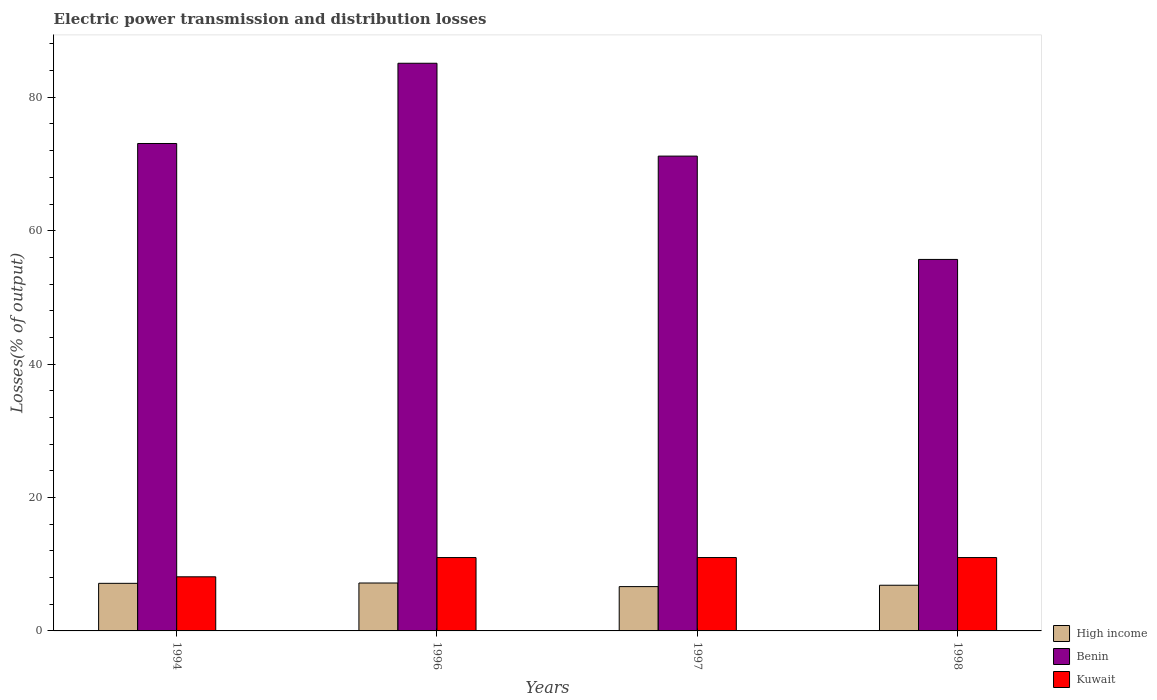How many different coloured bars are there?
Keep it short and to the point. 3. How many groups of bars are there?
Keep it short and to the point. 4. Are the number of bars per tick equal to the number of legend labels?
Keep it short and to the point. Yes. Are the number of bars on each tick of the X-axis equal?
Your answer should be compact. Yes. What is the electric power transmission and distribution losses in High income in 1994?
Provide a succinct answer. 7.14. Across all years, what is the maximum electric power transmission and distribution losses in Benin?
Provide a succinct answer. 85.11. Across all years, what is the minimum electric power transmission and distribution losses in Benin?
Keep it short and to the point. 55.7. In which year was the electric power transmission and distribution losses in High income maximum?
Your answer should be compact. 1996. In which year was the electric power transmission and distribution losses in Kuwait minimum?
Provide a short and direct response. 1994. What is the total electric power transmission and distribution losses in High income in the graph?
Make the answer very short. 27.81. What is the difference between the electric power transmission and distribution losses in Benin in 1997 and that in 1998?
Keep it short and to the point. 15.49. What is the difference between the electric power transmission and distribution losses in Benin in 1997 and the electric power transmission and distribution losses in High income in 1994?
Provide a succinct answer. 64.05. What is the average electric power transmission and distribution losses in Kuwait per year?
Your answer should be very brief. 10.28. In the year 1996, what is the difference between the electric power transmission and distribution losses in High income and electric power transmission and distribution losses in Kuwait?
Ensure brevity in your answer.  -3.82. What is the ratio of the electric power transmission and distribution losses in Kuwait in 1994 to that in 1997?
Provide a short and direct response. 0.74. Is the electric power transmission and distribution losses in High income in 1994 less than that in 1997?
Provide a short and direct response. No. Is the difference between the electric power transmission and distribution losses in High income in 1997 and 1998 greater than the difference between the electric power transmission and distribution losses in Kuwait in 1997 and 1998?
Provide a succinct answer. No. What is the difference between the highest and the second highest electric power transmission and distribution losses in Benin?
Make the answer very short. 12.03. What is the difference between the highest and the lowest electric power transmission and distribution losses in High income?
Give a very brief answer. 0.54. Is the sum of the electric power transmission and distribution losses in High income in 1994 and 1996 greater than the maximum electric power transmission and distribution losses in Benin across all years?
Give a very brief answer. No. What does the 3rd bar from the left in 1998 represents?
Provide a short and direct response. Kuwait. What does the 2nd bar from the right in 1998 represents?
Offer a terse response. Benin. How many years are there in the graph?
Offer a terse response. 4. What is the difference between two consecutive major ticks on the Y-axis?
Your response must be concise. 20. Are the values on the major ticks of Y-axis written in scientific E-notation?
Make the answer very short. No. Does the graph contain any zero values?
Provide a succinct answer. No. Does the graph contain grids?
Your answer should be very brief. No. Where does the legend appear in the graph?
Your response must be concise. Bottom right. How many legend labels are there?
Ensure brevity in your answer.  3. What is the title of the graph?
Your answer should be compact. Electric power transmission and distribution losses. Does "Australia" appear as one of the legend labels in the graph?
Your response must be concise. No. What is the label or title of the X-axis?
Your answer should be compact. Years. What is the label or title of the Y-axis?
Your response must be concise. Losses(% of output). What is the Losses(% of output) of High income in 1994?
Your response must be concise. 7.14. What is the Losses(% of output) of Benin in 1994?
Keep it short and to the point. 73.08. What is the Losses(% of output) in Kuwait in 1994?
Your answer should be very brief. 8.11. What is the Losses(% of output) in High income in 1996?
Make the answer very short. 7.18. What is the Losses(% of output) in Benin in 1996?
Offer a very short reply. 85.11. What is the Losses(% of output) of Kuwait in 1996?
Offer a very short reply. 11. What is the Losses(% of output) in High income in 1997?
Your answer should be very brief. 6.64. What is the Losses(% of output) in Benin in 1997?
Make the answer very short. 71.19. What is the Losses(% of output) in Kuwait in 1997?
Your answer should be compact. 11. What is the Losses(% of output) of High income in 1998?
Your answer should be very brief. 6.85. What is the Losses(% of output) of Benin in 1998?
Your answer should be compact. 55.7. What is the Losses(% of output) of Kuwait in 1998?
Your answer should be very brief. 11. Across all years, what is the maximum Losses(% of output) in High income?
Offer a terse response. 7.18. Across all years, what is the maximum Losses(% of output) of Benin?
Give a very brief answer. 85.11. Across all years, what is the maximum Losses(% of output) in Kuwait?
Provide a succinct answer. 11. Across all years, what is the minimum Losses(% of output) of High income?
Your answer should be compact. 6.64. Across all years, what is the minimum Losses(% of output) of Benin?
Provide a succinct answer. 55.7. Across all years, what is the minimum Losses(% of output) in Kuwait?
Your answer should be compact. 8.11. What is the total Losses(% of output) in High income in the graph?
Provide a succinct answer. 27.81. What is the total Losses(% of output) in Benin in the graph?
Your response must be concise. 285.07. What is the total Losses(% of output) of Kuwait in the graph?
Make the answer very short. 41.11. What is the difference between the Losses(% of output) in High income in 1994 and that in 1996?
Provide a short and direct response. -0.05. What is the difference between the Losses(% of output) of Benin in 1994 and that in 1996?
Ensure brevity in your answer.  -12.03. What is the difference between the Losses(% of output) in Kuwait in 1994 and that in 1996?
Offer a terse response. -2.89. What is the difference between the Losses(% of output) in High income in 1994 and that in 1997?
Offer a terse response. 0.49. What is the difference between the Losses(% of output) in Benin in 1994 and that in 1997?
Offer a terse response. 1.89. What is the difference between the Losses(% of output) of Kuwait in 1994 and that in 1997?
Ensure brevity in your answer.  -2.89. What is the difference between the Losses(% of output) of High income in 1994 and that in 1998?
Make the answer very short. 0.29. What is the difference between the Losses(% of output) in Benin in 1994 and that in 1998?
Your answer should be compact. 17.38. What is the difference between the Losses(% of output) in Kuwait in 1994 and that in 1998?
Offer a very short reply. -2.89. What is the difference between the Losses(% of output) of High income in 1996 and that in 1997?
Keep it short and to the point. 0.54. What is the difference between the Losses(% of output) in Benin in 1996 and that in 1997?
Offer a very short reply. 13.92. What is the difference between the Losses(% of output) in Kuwait in 1996 and that in 1997?
Make the answer very short. -0. What is the difference between the Losses(% of output) in High income in 1996 and that in 1998?
Keep it short and to the point. 0.34. What is the difference between the Losses(% of output) in Benin in 1996 and that in 1998?
Ensure brevity in your answer.  29.41. What is the difference between the Losses(% of output) of Kuwait in 1996 and that in 1998?
Your response must be concise. -0. What is the difference between the Losses(% of output) in High income in 1997 and that in 1998?
Offer a terse response. -0.2. What is the difference between the Losses(% of output) of Benin in 1997 and that in 1998?
Your response must be concise. 15.49. What is the difference between the Losses(% of output) in Kuwait in 1997 and that in 1998?
Your response must be concise. 0. What is the difference between the Losses(% of output) of High income in 1994 and the Losses(% of output) of Benin in 1996?
Make the answer very short. -77.97. What is the difference between the Losses(% of output) in High income in 1994 and the Losses(% of output) in Kuwait in 1996?
Your response must be concise. -3.86. What is the difference between the Losses(% of output) of Benin in 1994 and the Losses(% of output) of Kuwait in 1996?
Your response must be concise. 62.08. What is the difference between the Losses(% of output) of High income in 1994 and the Losses(% of output) of Benin in 1997?
Offer a terse response. -64.05. What is the difference between the Losses(% of output) of High income in 1994 and the Losses(% of output) of Kuwait in 1997?
Offer a very short reply. -3.87. What is the difference between the Losses(% of output) in Benin in 1994 and the Losses(% of output) in Kuwait in 1997?
Your answer should be very brief. 62.08. What is the difference between the Losses(% of output) of High income in 1994 and the Losses(% of output) of Benin in 1998?
Your answer should be compact. -48.56. What is the difference between the Losses(% of output) in High income in 1994 and the Losses(% of output) in Kuwait in 1998?
Your answer should be compact. -3.86. What is the difference between the Losses(% of output) in Benin in 1994 and the Losses(% of output) in Kuwait in 1998?
Your response must be concise. 62.08. What is the difference between the Losses(% of output) of High income in 1996 and the Losses(% of output) of Benin in 1997?
Offer a very short reply. -64. What is the difference between the Losses(% of output) in High income in 1996 and the Losses(% of output) in Kuwait in 1997?
Your answer should be very brief. -3.82. What is the difference between the Losses(% of output) in Benin in 1996 and the Losses(% of output) in Kuwait in 1997?
Give a very brief answer. 74.11. What is the difference between the Losses(% of output) in High income in 1996 and the Losses(% of output) in Benin in 1998?
Offer a very short reply. -48.51. What is the difference between the Losses(% of output) of High income in 1996 and the Losses(% of output) of Kuwait in 1998?
Provide a succinct answer. -3.82. What is the difference between the Losses(% of output) of Benin in 1996 and the Losses(% of output) of Kuwait in 1998?
Provide a succinct answer. 74.11. What is the difference between the Losses(% of output) in High income in 1997 and the Losses(% of output) in Benin in 1998?
Make the answer very short. -49.05. What is the difference between the Losses(% of output) of High income in 1997 and the Losses(% of output) of Kuwait in 1998?
Offer a terse response. -4.35. What is the difference between the Losses(% of output) of Benin in 1997 and the Losses(% of output) of Kuwait in 1998?
Give a very brief answer. 60.19. What is the average Losses(% of output) of High income per year?
Ensure brevity in your answer.  6.95. What is the average Losses(% of output) in Benin per year?
Keep it short and to the point. 71.27. What is the average Losses(% of output) in Kuwait per year?
Keep it short and to the point. 10.28. In the year 1994, what is the difference between the Losses(% of output) in High income and Losses(% of output) in Benin?
Give a very brief answer. -65.94. In the year 1994, what is the difference between the Losses(% of output) in High income and Losses(% of output) in Kuwait?
Your response must be concise. -0.98. In the year 1994, what is the difference between the Losses(% of output) of Benin and Losses(% of output) of Kuwait?
Offer a terse response. 64.96. In the year 1996, what is the difference between the Losses(% of output) in High income and Losses(% of output) in Benin?
Keep it short and to the point. -77.92. In the year 1996, what is the difference between the Losses(% of output) of High income and Losses(% of output) of Kuwait?
Your response must be concise. -3.82. In the year 1996, what is the difference between the Losses(% of output) of Benin and Losses(% of output) of Kuwait?
Offer a terse response. 74.11. In the year 1997, what is the difference between the Losses(% of output) in High income and Losses(% of output) in Benin?
Provide a short and direct response. -64.54. In the year 1997, what is the difference between the Losses(% of output) in High income and Losses(% of output) in Kuwait?
Make the answer very short. -4.36. In the year 1997, what is the difference between the Losses(% of output) of Benin and Losses(% of output) of Kuwait?
Keep it short and to the point. 60.19. In the year 1998, what is the difference between the Losses(% of output) in High income and Losses(% of output) in Benin?
Keep it short and to the point. -48.85. In the year 1998, what is the difference between the Losses(% of output) in High income and Losses(% of output) in Kuwait?
Your response must be concise. -4.15. In the year 1998, what is the difference between the Losses(% of output) of Benin and Losses(% of output) of Kuwait?
Give a very brief answer. 44.7. What is the ratio of the Losses(% of output) of High income in 1994 to that in 1996?
Offer a very short reply. 0.99. What is the ratio of the Losses(% of output) of Benin in 1994 to that in 1996?
Your answer should be very brief. 0.86. What is the ratio of the Losses(% of output) of Kuwait in 1994 to that in 1996?
Your response must be concise. 0.74. What is the ratio of the Losses(% of output) of High income in 1994 to that in 1997?
Provide a short and direct response. 1.07. What is the ratio of the Losses(% of output) of Benin in 1994 to that in 1997?
Offer a terse response. 1.03. What is the ratio of the Losses(% of output) of Kuwait in 1994 to that in 1997?
Your response must be concise. 0.74. What is the ratio of the Losses(% of output) in High income in 1994 to that in 1998?
Provide a short and direct response. 1.04. What is the ratio of the Losses(% of output) in Benin in 1994 to that in 1998?
Your answer should be very brief. 1.31. What is the ratio of the Losses(% of output) in Kuwait in 1994 to that in 1998?
Ensure brevity in your answer.  0.74. What is the ratio of the Losses(% of output) of High income in 1996 to that in 1997?
Offer a very short reply. 1.08. What is the ratio of the Losses(% of output) in Benin in 1996 to that in 1997?
Make the answer very short. 1.2. What is the ratio of the Losses(% of output) of Kuwait in 1996 to that in 1997?
Provide a short and direct response. 1. What is the ratio of the Losses(% of output) in High income in 1996 to that in 1998?
Provide a succinct answer. 1.05. What is the ratio of the Losses(% of output) of Benin in 1996 to that in 1998?
Provide a succinct answer. 1.53. What is the ratio of the Losses(% of output) in High income in 1997 to that in 1998?
Provide a short and direct response. 0.97. What is the ratio of the Losses(% of output) of Benin in 1997 to that in 1998?
Keep it short and to the point. 1.28. What is the difference between the highest and the second highest Losses(% of output) in High income?
Ensure brevity in your answer.  0.05. What is the difference between the highest and the second highest Losses(% of output) in Benin?
Ensure brevity in your answer.  12.03. What is the difference between the highest and the second highest Losses(% of output) in Kuwait?
Ensure brevity in your answer.  0. What is the difference between the highest and the lowest Losses(% of output) of High income?
Provide a short and direct response. 0.54. What is the difference between the highest and the lowest Losses(% of output) of Benin?
Give a very brief answer. 29.41. What is the difference between the highest and the lowest Losses(% of output) of Kuwait?
Your answer should be compact. 2.89. 